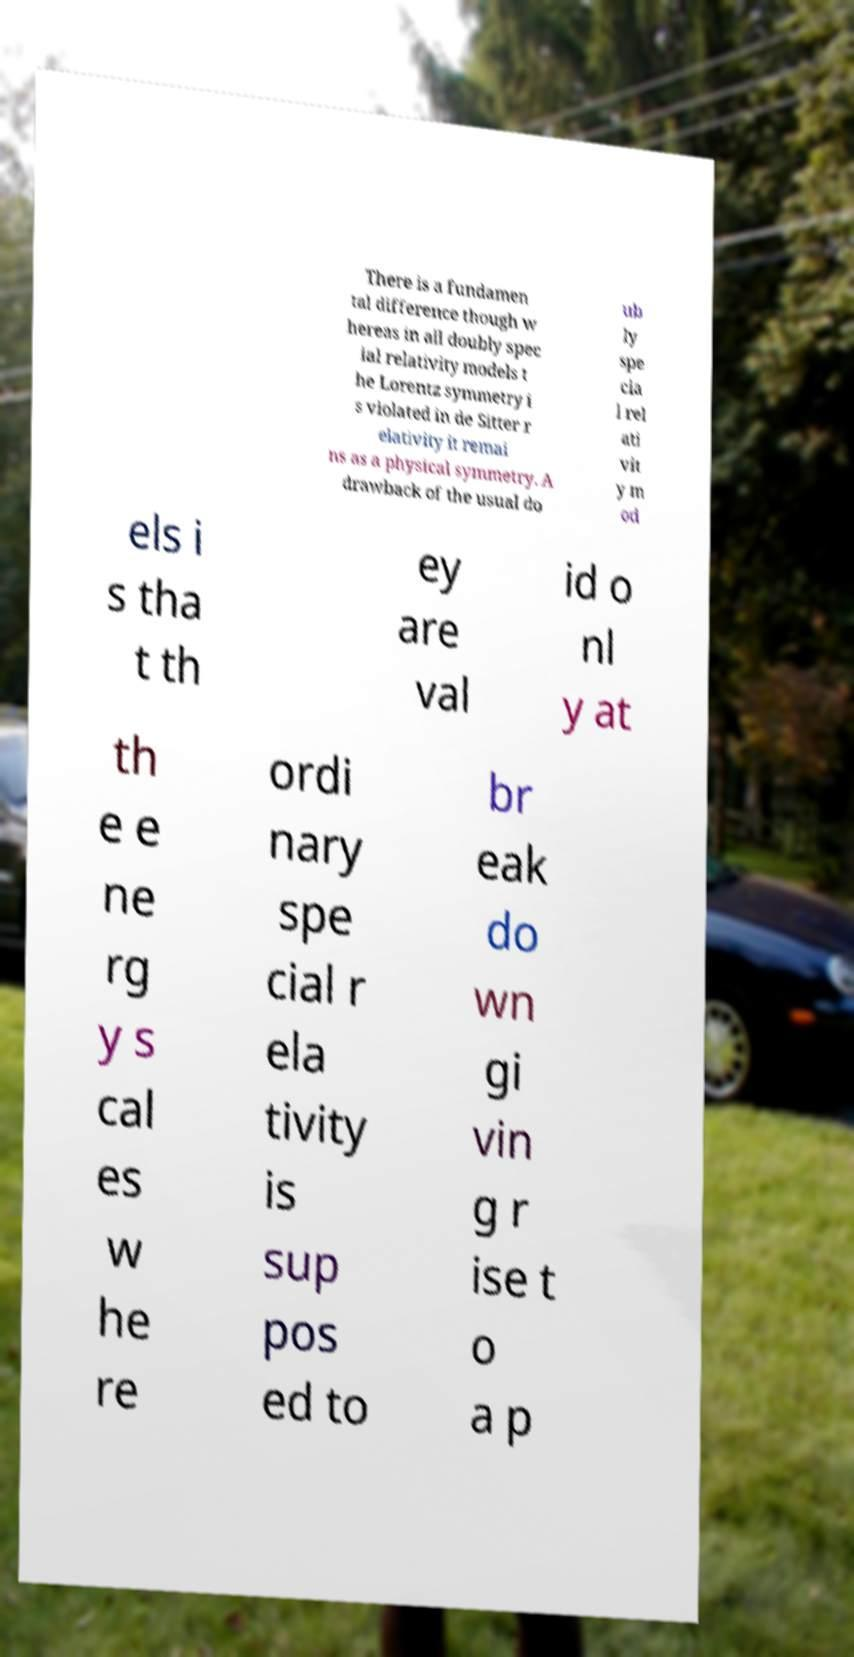Please identify and transcribe the text found in this image. There is a fundamen tal difference though w hereas in all doubly spec ial relativity models t he Lorentz symmetry i s violated in de Sitter r elativity it remai ns as a physical symmetry. A drawback of the usual do ub ly spe cia l rel ati vit y m od els i s tha t th ey are val id o nl y at th e e ne rg y s cal es w he re ordi nary spe cial r ela tivity is sup pos ed to br eak do wn gi vin g r ise t o a p 